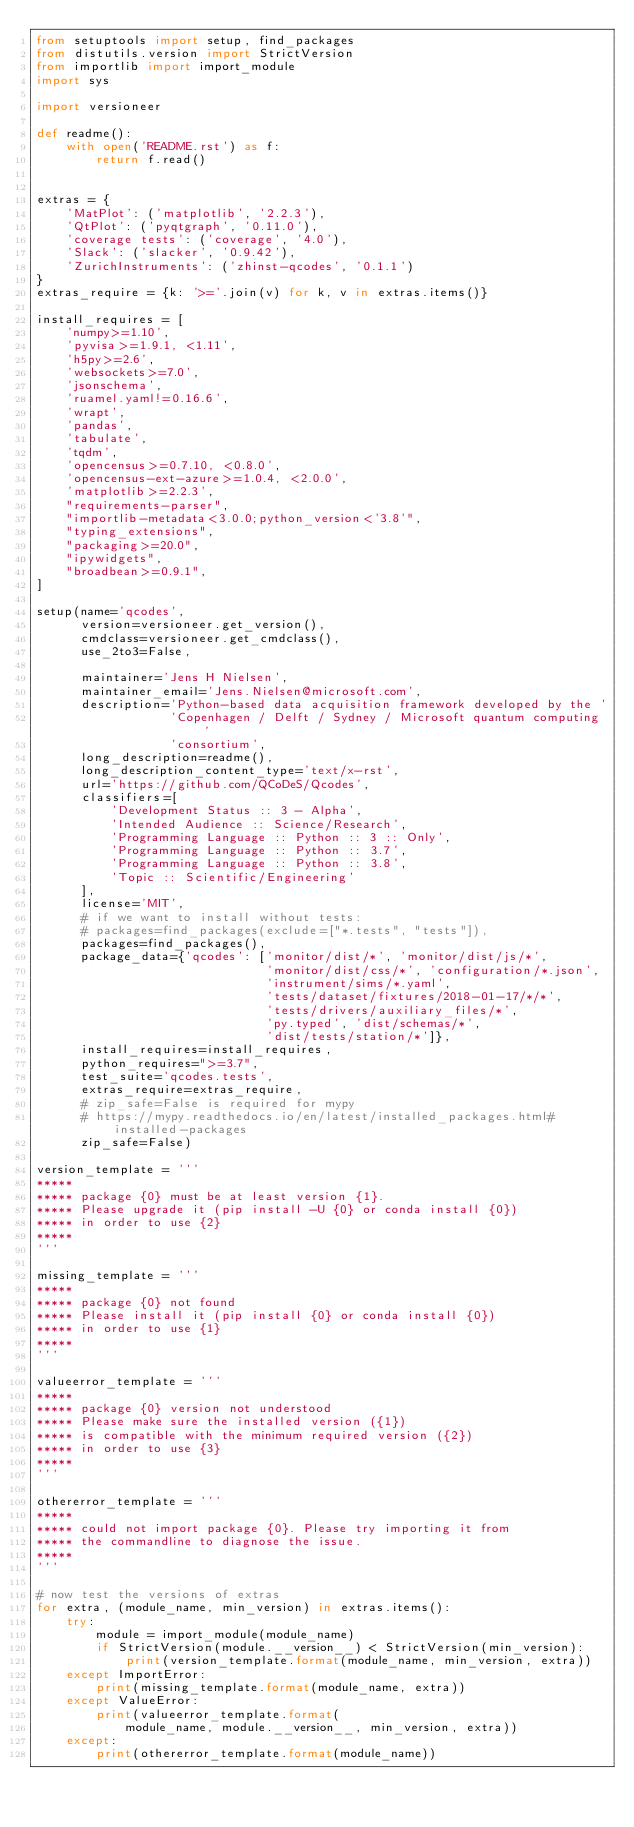Convert code to text. <code><loc_0><loc_0><loc_500><loc_500><_Python_>from setuptools import setup, find_packages
from distutils.version import StrictVersion
from importlib import import_module
import sys

import versioneer

def readme():
    with open('README.rst') as f:
        return f.read()


extras = {
    'MatPlot': ('matplotlib', '2.2.3'),
    'QtPlot': ('pyqtgraph', '0.11.0'),
    'coverage tests': ('coverage', '4.0'),
    'Slack': ('slacker', '0.9.42'),
    'ZurichInstruments': ('zhinst-qcodes', '0.1.1')
}
extras_require = {k: '>='.join(v) for k, v in extras.items()}

install_requires = [
    'numpy>=1.10',
    'pyvisa>=1.9.1, <1.11',
    'h5py>=2.6',
    'websockets>=7.0',
    'jsonschema',
    'ruamel.yaml!=0.16.6',
    'wrapt',
    'pandas',
    'tabulate',
    'tqdm',
    'opencensus>=0.7.10, <0.8.0',
    'opencensus-ext-azure>=1.0.4, <2.0.0',
    'matplotlib>=2.2.3',
    "requirements-parser",
    "importlib-metadata<3.0.0;python_version<'3.8'",
    "typing_extensions",
    "packaging>=20.0",
    "ipywidgets",
    "broadbean>=0.9.1",
]

setup(name='qcodes',
      version=versioneer.get_version(),
      cmdclass=versioneer.get_cmdclass(),
      use_2to3=False,

      maintainer='Jens H Nielsen',
      maintainer_email='Jens.Nielsen@microsoft.com',
      description='Python-based data acquisition framework developed by the '
                  'Copenhagen / Delft / Sydney / Microsoft quantum computing '
                  'consortium',
      long_description=readme(),
      long_description_content_type='text/x-rst',
      url='https://github.com/QCoDeS/Qcodes',
      classifiers=[
          'Development Status :: 3 - Alpha',
          'Intended Audience :: Science/Research',
          'Programming Language :: Python :: 3 :: Only',
          'Programming Language :: Python :: 3.7',
          'Programming Language :: Python :: 3.8',
          'Topic :: Scientific/Engineering'
      ],
      license='MIT',
      # if we want to install without tests:
      # packages=find_packages(exclude=["*.tests", "tests"]),
      packages=find_packages(),
      package_data={'qcodes': ['monitor/dist/*', 'monitor/dist/js/*',
                               'monitor/dist/css/*', 'configuration/*.json',
                               'instrument/sims/*.yaml',
                               'tests/dataset/fixtures/2018-01-17/*/*',
                               'tests/drivers/auxiliary_files/*',
                               'py.typed', 'dist/schemas/*',
                               'dist/tests/station/*']},
      install_requires=install_requires,
      python_requires=">=3.7",
      test_suite='qcodes.tests',
      extras_require=extras_require,
      # zip_safe=False is required for mypy
      # https://mypy.readthedocs.io/en/latest/installed_packages.html#installed-packages
      zip_safe=False)

version_template = '''
*****
***** package {0} must be at least version {1}.
***** Please upgrade it (pip install -U {0} or conda install {0})
***** in order to use {2}
*****
'''

missing_template = '''
*****
***** package {0} not found
***** Please install it (pip install {0} or conda install {0})
***** in order to use {1}
*****
'''

valueerror_template = '''
*****
***** package {0} version not understood
***** Please make sure the installed version ({1})
***** is compatible with the minimum required version ({2})
***** in order to use {3}
*****
'''

othererror_template = '''
*****
***** could not import package {0}. Please try importing it from
***** the commandline to diagnose the issue.
*****
'''

# now test the versions of extras
for extra, (module_name, min_version) in extras.items():
    try:
        module = import_module(module_name)
        if StrictVersion(module.__version__) < StrictVersion(min_version):
            print(version_template.format(module_name, min_version, extra))
    except ImportError:
        print(missing_template.format(module_name, extra))
    except ValueError:
        print(valueerror_template.format(
            module_name, module.__version__, min_version, extra))
    except:
        print(othererror_template.format(module_name))
</code> 